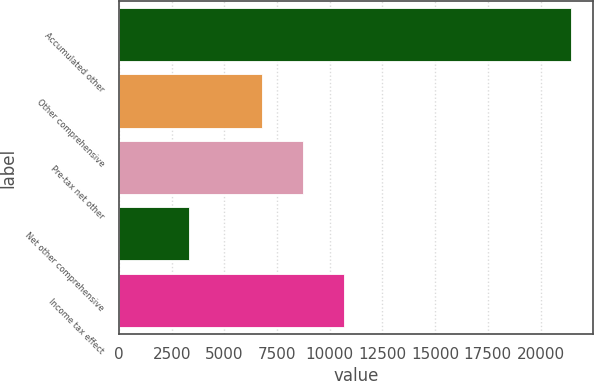<chart> <loc_0><loc_0><loc_500><loc_500><bar_chart><fcel>Accumulated other<fcel>Other comprehensive<fcel>Pre-tax net other<fcel>Net other comprehensive<fcel>Income tax effect<nl><fcel>21423.6<fcel>6767<fcel>8714.6<fcel>3315<fcel>10662.2<nl></chart> 